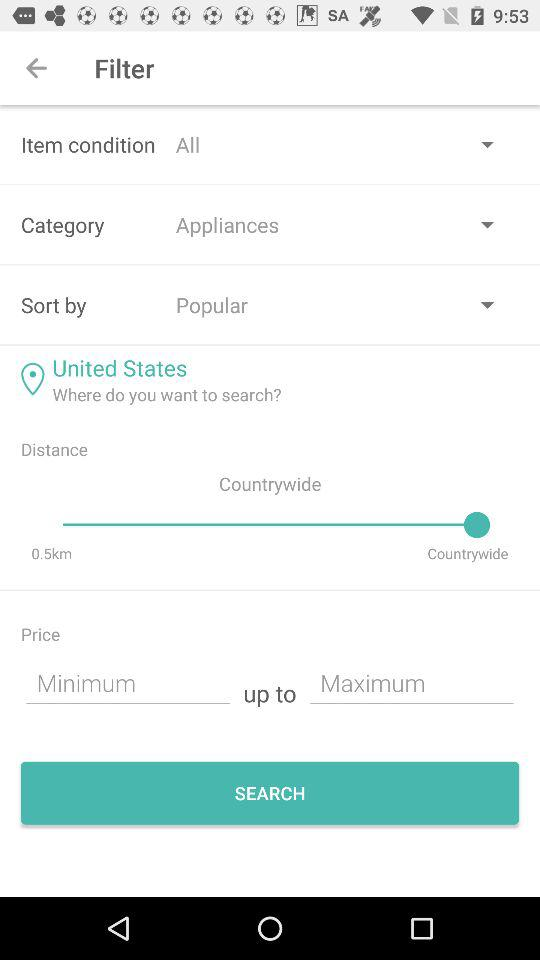What is specified in the sort by filter option? In the filter option, sort by popular. 